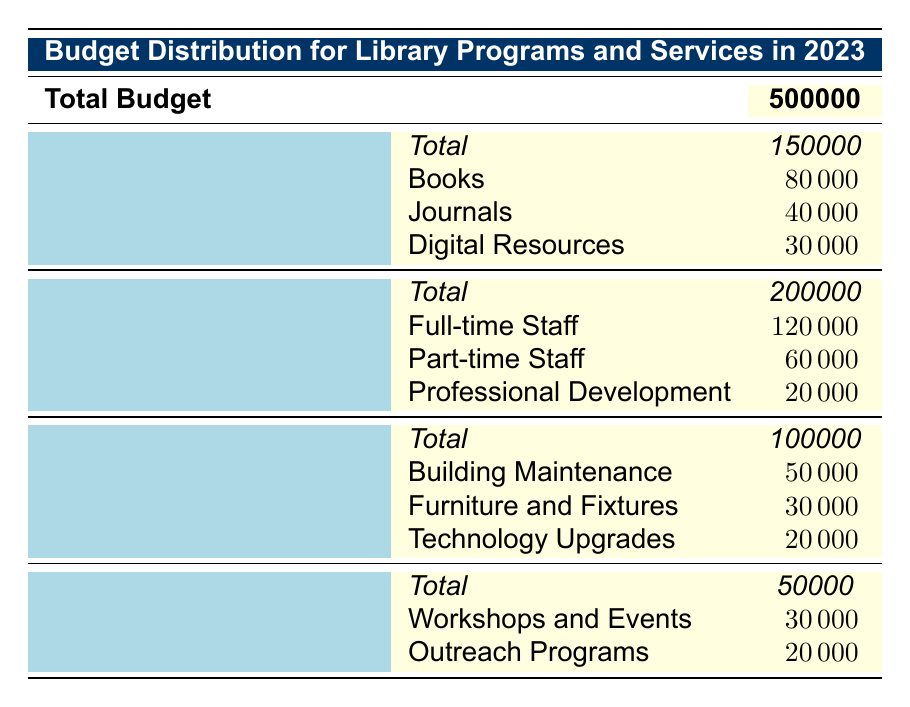What is the total budget allocated for Staffing? According to the table, the “Staffing” category has an allocated amount of 200000.
Answer: 200000 How much is allocated for Digital Resources in Collections Development? The table shows that under the “Collections Development” category, the “Digital Resources” subcategory has an amount of 30000.
Answer: 30000 Is the budget for Workshops and Events greater than the budget for Outreach Programs? The table indicates that the budget for “Workshops and Events” is 30000, while for “Outreach Programs” it is 20000. Since 30000 is greater than 20000, the statement is true.
Answer: Yes What is the total amount allocated to Facilities and Equipment? The allocated amount for the “Facilities and Equipment” category is listed as 100000 in the table.
Answer: 100000 If you sum the allocated amounts for all subcategories under Staffing, what is the total? To find the total for Staffing, we sum the amounts for full-time staff (120000), part-time staff (60000), and professional development (20000). Adding these gives us 120000 + 60000 + 20000 = 200000, which matches the total allocated for Staffing.
Answer: 200000 How much more is allocated for Books compared to Journals? The amount for Books is 80000 and for Journals is 40000. The difference is 80000 - 40000 = 40000. Therefore, 40000 more is allocated for Books compared to Journals.
Answer: 40000 Is the total budget for Programs and Services less than 60000? The total budget for “Programs and Services” is 50000 according to the table. Since 50000 is less than 60000, the statement is true.
Answer: Yes What is the average allocation per subcategory in the Collections Development category? There are 3 subcategories in Collections Development: Books (80000), Journals (40000), and Digital Resources (30000). To find the average, add these amounts: 80000 + 40000 + 30000 = 150000. Divide by the number of subcategories (3) to get 150000 / 3 = 50000.
Answer: 50000 If the total budget is divided equally among the four main categories, how much would each category receive? The total budget is 500000, and there are 4 categories. Dividing gives 500000 / 4 = 125000, so each category would receive 125000.
Answer: 125000 